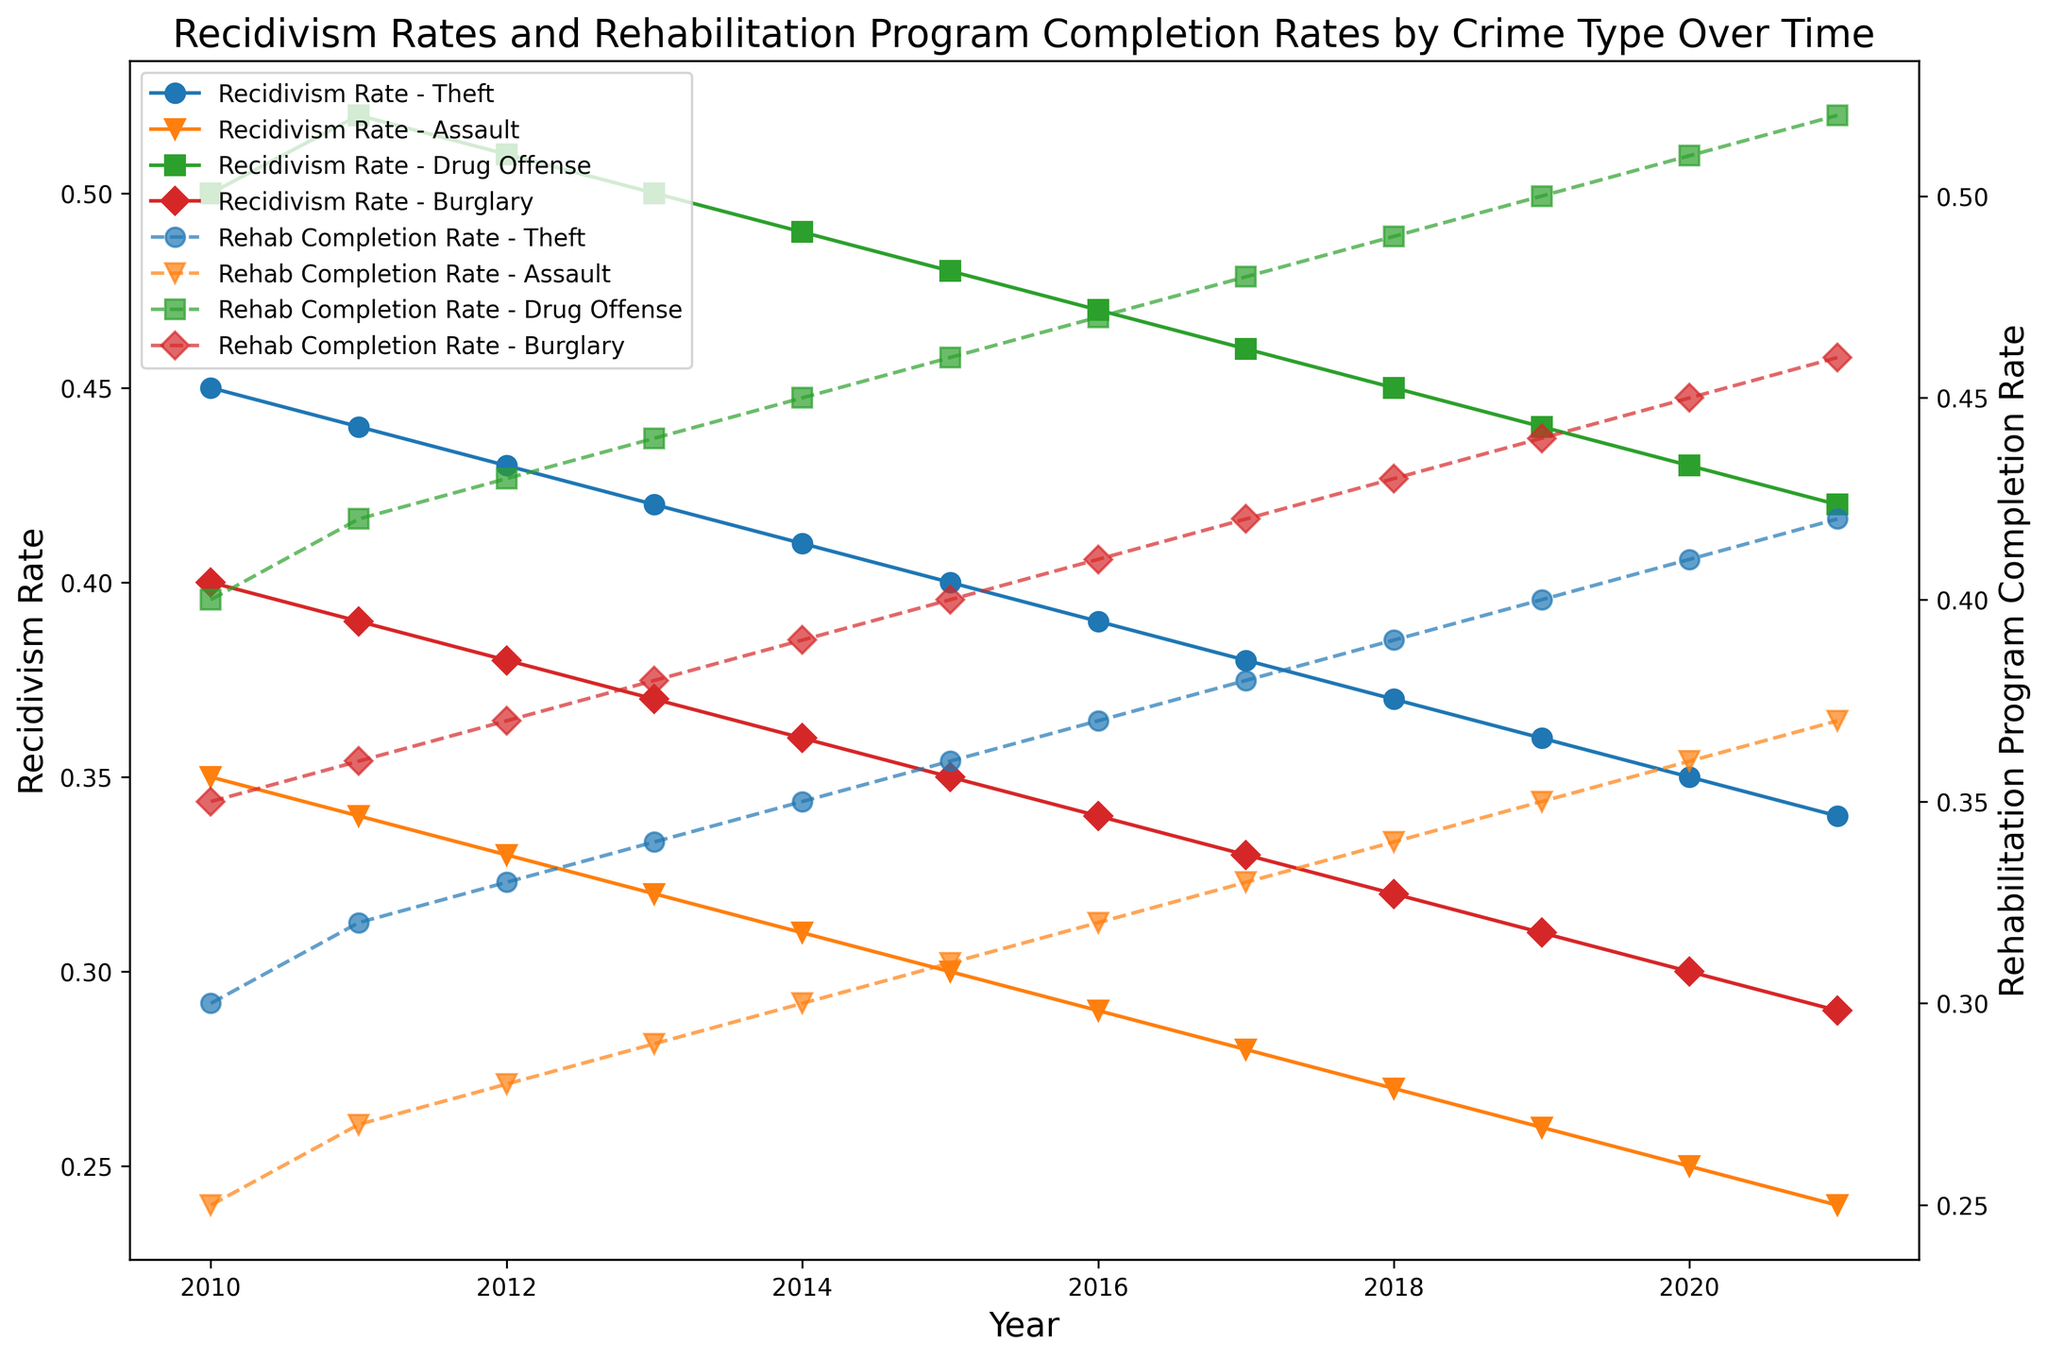What was the rehabilitation program completion rate for Assault in 2013? By locating the series line for Assault and finding the value corresponding to 2013 on the secondary y-axis for Rehabilitation Program Completion Rate, we can see that it is 0.29.
Answer: 0.29 Which crime type showed a continuous decrease in recidivism rate from 2010 to 2021? From the recidivism rate lines on the primary y-axis, we can see that Assault had a steady decline without any increase from 2010 to 2021.
Answer: Assault Compare the recidivism rates of Theft and Burglary in 2015. Which one was higher? Checking the recidivism rate lines for Theft and Burglary in 2015 on the primary y-axis, Theft was higher at 0.40 compared to Burglary at 0.35.
Answer: Theft What is the difference in recidivism rates between Drug Offense and Assault in 2020? On the primary y-axis, find the recidivism rate for Drug Offense (0.43) and Assault (0.25) in 2020. The difference is 0.43 - 0.25 = 0.18.
Answer: 0.18 Did the rehabilitation program completion rate for Drug Offense in 2021 increase or decrease compared to 2020? By comparing the series line for Drug Offense on the secondary y-axis, we see that it increased from 0.51 in 2020 to 0.52 in 2021.
Answer: Increased Which crime type had the lowest recidivism rate in 2019? Observing the recidivism rate lines on the primary y-axis for 2019, Assault had the lowest rate at 0.26.
Answer: Assault How many crime types reached a recidivism rate below 0.30 in 2021? On the primary y-axis for 2021, both Assault (0.24) and Burglary (0.29) had recidivism rates below 0.30. So, two crime types reached below 0.30.
Answer: 2 Was the rehabilitation program completion rate for Theft higher in 2015 or 2017? Compare the secondary y-axis values for Theft in both years: 0.36 in 2015 and 0.38 in 2017; 0.38 is higher.
Answer: 2017 What was the trend in recidivism rates for Drug Offense from 2010 to 2021? Referring to the series line for Drug Offense on the primary y-axis, we observe a gradual overall decline from 0.50 in 2010 to 0.42 in 2021.
Answer: Decline On average, did burglary recidivism rates increase or decrease between 2010 and 2021? Observing the burglary recidivism rate line on the primary y-axis from 2010 (0.40) to 2021 (0.29), there is a regression suggesting an overall decreasing trend.
Answer: Decrease 